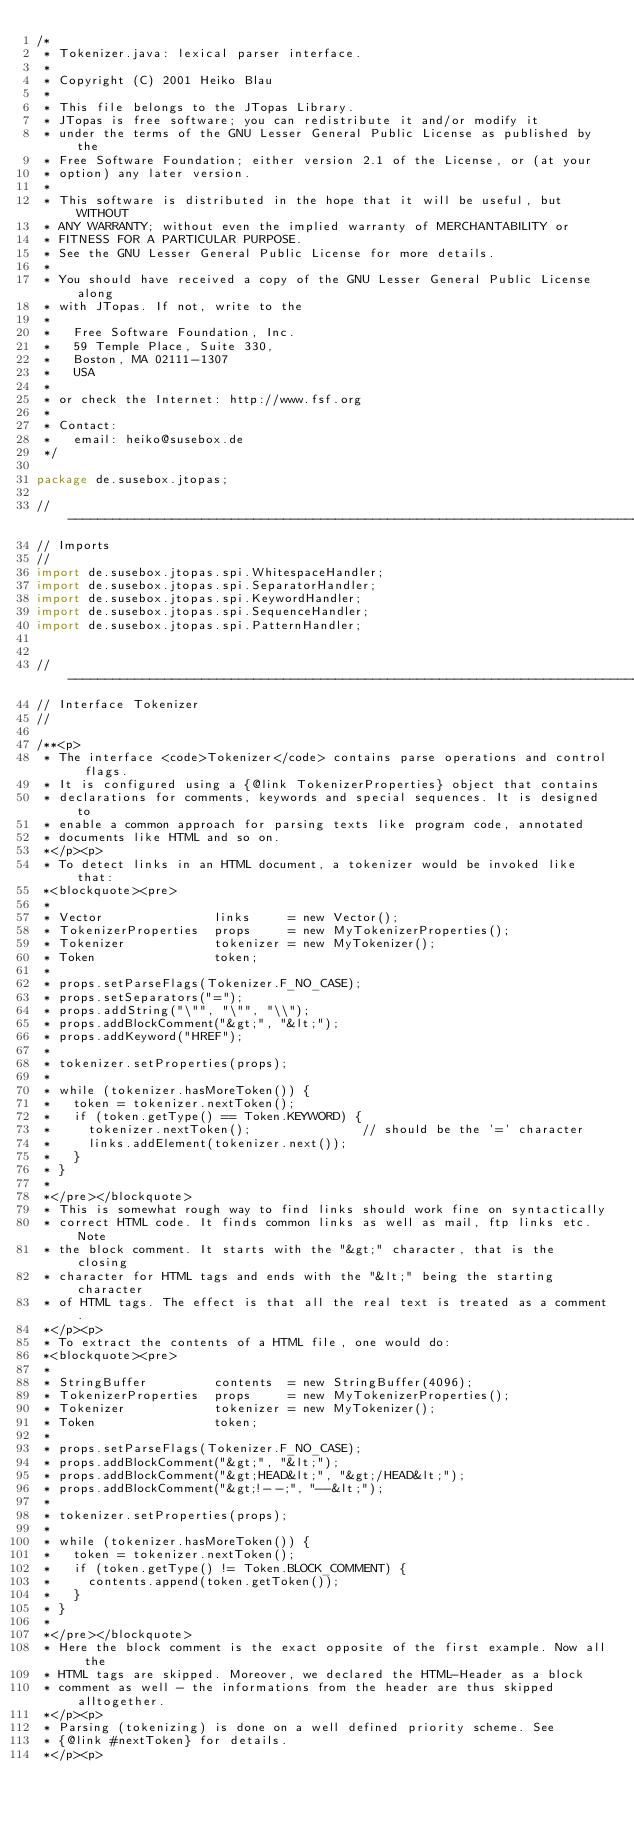<code> <loc_0><loc_0><loc_500><loc_500><_Java_>/*
 * Tokenizer.java: lexical parser interface.
 *
 * Copyright (C) 2001 Heiko Blau
 *
 * This file belongs to the JTopas Library.
 * JTopas is free software; you can redistribute it and/or modify it 
 * under the terms of the GNU Lesser General Public License as published by the 
 * Free Software Foundation; either version 2.1 of the License, or (at your 
 * option) any later version.
 *
 * This software is distributed in the hope that it will be useful, but WITHOUT
 * ANY WARRANTY; without even the implied warranty of MERCHANTABILITY or 
 * FITNESS FOR A PARTICULAR PURPOSE. 
 * See the GNU Lesser General Public License for more details.
 *
 * You should have received a copy of the GNU Lesser General Public License along
 * with JTopas. If not, write to the
 *
 *   Free Software Foundation, Inc.
 *   59 Temple Place, Suite 330, 
 *   Boston, MA 02111-1307 
 *   USA
 *
 * or check the Internet: http://www.fsf.org
 *
 * Contact:
 *   email: heiko@susebox.de 
 */

package de.susebox.jtopas;

//-----------------------------------------------------------------------------
// Imports
//
import de.susebox.jtopas.spi.WhitespaceHandler;
import de.susebox.jtopas.spi.SeparatorHandler;
import de.susebox.jtopas.spi.KeywordHandler;
import de.susebox.jtopas.spi.SequenceHandler;
import de.susebox.jtopas.spi.PatternHandler;


//-----------------------------------------------------------------------------
// Interface Tokenizer
//

/**<p>
 * The interface <code>Tokenizer</code> contains parse operations and control flags.
 * It is configured using a {@link TokenizerProperties} object that contains 
 * declarations for comments, keywords and special sequences. It is designed to 
 * enable a common approach for parsing texts like program code, annotated 
 * documents like HTML and so on.
 *</p><p>
 * To detect links in an HTML document, a tokenizer would be invoked like that:
 *<blockquote><pre>
 *
 * Vector               links     = new Vector();
 * TokenizerProperties  props     = new MyTokenizerProperties();
 * Tokenizer            tokenizer = new MyTokenizer();
 * Token                token;
 *
 * props.setParseFlags(Tokenizer.F_NO_CASE);
 * props.setSeparators("=");
 * props.addString("\"", "\"", "\\");
 * props.addBlockComment("&gt;", "&lt;");
 * props.addKeyword("HREF");
 *
 * tokenizer.setProperties(props);
 *
 * while (tokenizer.hasMoreToken()) {
 *   token = tokenizer.nextToken();
 *   if (token.getType() == Token.KEYWORD) {
 *     tokenizer.nextToken();               // should be the '=' character
 *     links.addElement(tokenizer.next());
 *   }
 * }
 *
 *</pre></blockquote>
 * This is somewhat rough way to find links should work fine on syntactically
 * correct HTML code. It finds common links as well as mail, ftp links etc. Note
 * the block comment. It starts with the "&gt;" character, that is the closing
 * character for HTML tags and ends with the "&lt;" being the starting character
 * of HTML tags. The effect is that all the real text is treated as a comment.
 *</p><p>
 * To extract the contents of a HTML file, one would do:
 *<blockquote><pre>
 *
 * StringBuffer         contents  = new StringBuffer(4096);
 * TokenizerProperties  props     = new MyTokenizerProperties();
 * Tokenizer            tokenizer = new MyTokenizer();
 * Token                token;
 *
 * props.setParseFlags(Tokenizer.F_NO_CASE);
 * props.addBlockComment("&gt;", "&lt;");
 * props.addBlockComment("&gt;HEAD&lt;", "&gt;/HEAD&lt;");
 * props.addBlockComment("&gt;!--;", "--&lt;");
 *    
 * tokenizer.setProperties(props);
 *
 * while (tokenizer.hasMoreToken()) {
 *   token = tokenizer.nextToken();
 *   if (token.getType() != Token.BLOCK_COMMENT) {
 *     contents.append(token.getToken());
 *   }
 * }
 *
 *</pre></blockquote>
 * Here the block comment is the exact opposite of the first example. Now all the
 * HTML tags are skipped. Moreover, we declared the HTML-Header as a block
 * comment as well - the informations from the header are thus skipped alltogether.
 *</p><p>
 * Parsing (tokenizing) is done on a well defined priority scheme. See 
 * {@link #nextToken} for details.
 *</p><p></code> 